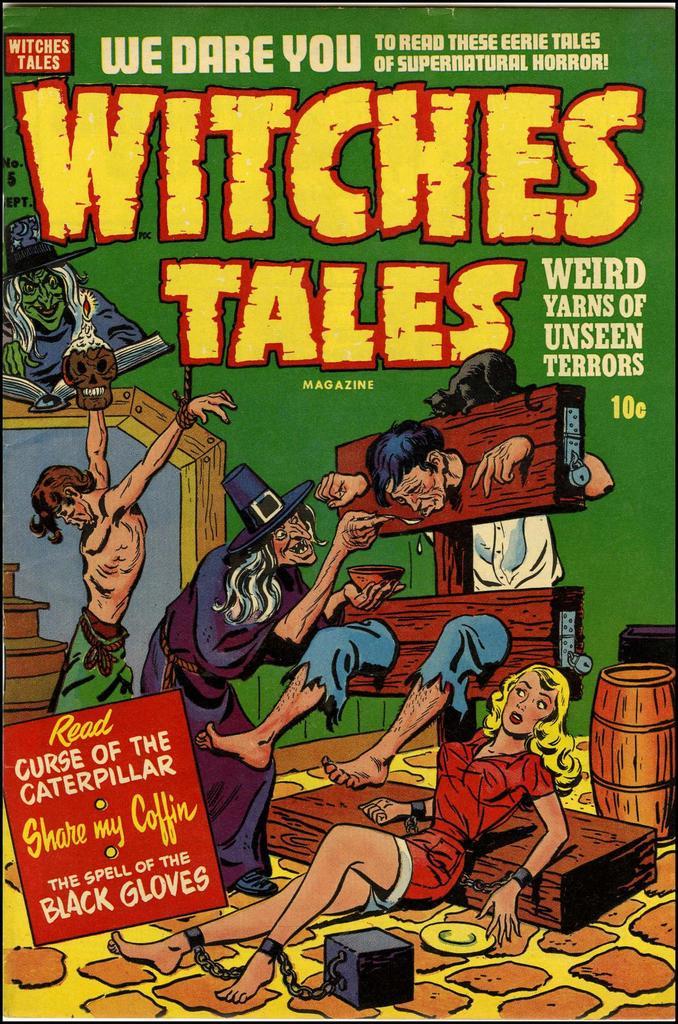How much does it cost to buy this magazine?
Your response must be concise. 10 cents. What kind of tales are these?
Your answer should be compact. Witches. 